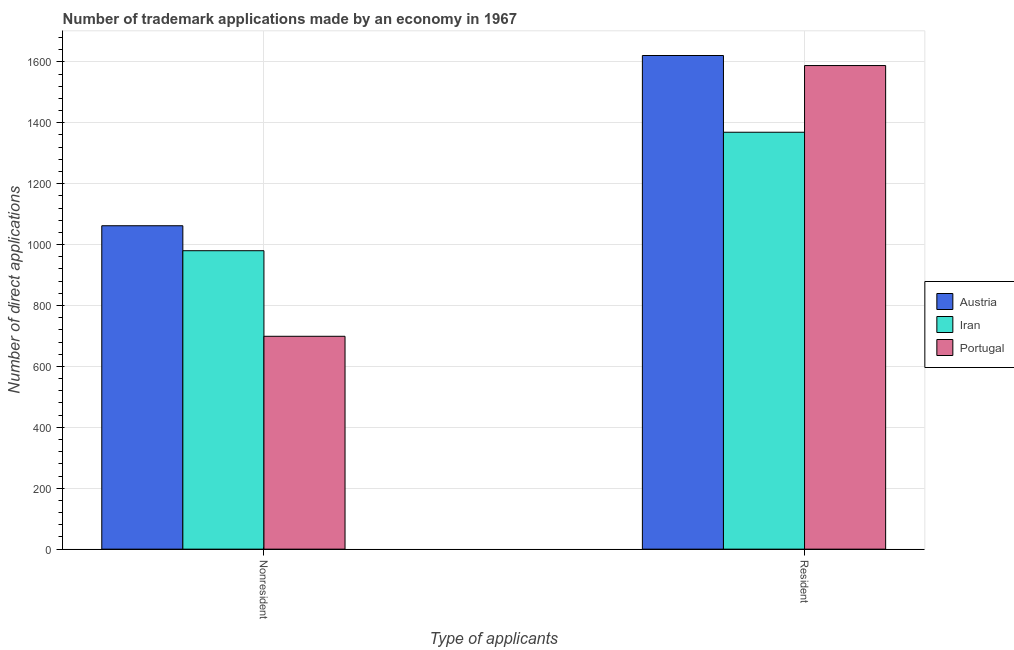How many bars are there on the 2nd tick from the left?
Offer a very short reply. 3. What is the label of the 1st group of bars from the left?
Your response must be concise. Nonresident. What is the number of trademark applications made by non residents in Portugal?
Provide a short and direct response. 699. Across all countries, what is the maximum number of trademark applications made by residents?
Your response must be concise. 1621. Across all countries, what is the minimum number of trademark applications made by residents?
Provide a succinct answer. 1369. In which country was the number of trademark applications made by residents minimum?
Your answer should be very brief. Iran. What is the total number of trademark applications made by residents in the graph?
Provide a short and direct response. 4578. What is the difference between the number of trademark applications made by non residents in Austria and that in Iran?
Provide a succinct answer. 82. What is the difference between the number of trademark applications made by residents in Iran and the number of trademark applications made by non residents in Austria?
Your response must be concise. 307. What is the average number of trademark applications made by non residents per country?
Provide a succinct answer. 913.67. What is the difference between the number of trademark applications made by non residents and number of trademark applications made by residents in Iran?
Give a very brief answer. -389. In how many countries, is the number of trademark applications made by non residents greater than 360 ?
Your answer should be compact. 3. What is the ratio of the number of trademark applications made by non residents in Iran to that in Austria?
Ensure brevity in your answer.  0.92. What does the 2nd bar from the left in Resident represents?
Offer a very short reply. Iran. What does the 1st bar from the right in Resident represents?
Give a very brief answer. Portugal. Are all the bars in the graph horizontal?
Give a very brief answer. No. What is the difference between two consecutive major ticks on the Y-axis?
Make the answer very short. 200. Does the graph contain grids?
Your response must be concise. Yes. Where does the legend appear in the graph?
Offer a terse response. Center right. How are the legend labels stacked?
Offer a terse response. Vertical. What is the title of the graph?
Your answer should be compact. Number of trademark applications made by an economy in 1967. What is the label or title of the X-axis?
Your response must be concise. Type of applicants. What is the label or title of the Y-axis?
Ensure brevity in your answer.  Number of direct applications. What is the Number of direct applications in Austria in Nonresident?
Your answer should be compact. 1062. What is the Number of direct applications of Iran in Nonresident?
Provide a short and direct response. 980. What is the Number of direct applications of Portugal in Nonresident?
Offer a terse response. 699. What is the Number of direct applications in Austria in Resident?
Keep it short and to the point. 1621. What is the Number of direct applications in Iran in Resident?
Provide a short and direct response. 1369. What is the Number of direct applications of Portugal in Resident?
Your answer should be very brief. 1588. Across all Type of applicants, what is the maximum Number of direct applications in Austria?
Provide a succinct answer. 1621. Across all Type of applicants, what is the maximum Number of direct applications of Iran?
Provide a succinct answer. 1369. Across all Type of applicants, what is the maximum Number of direct applications of Portugal?
Provide a succinct answer. 1588. Across all Type of applicants, what is the minimum Number of direct applications in Austria?
Provide a succinct answer. 1062. Across all Type of applicants, what is the minimum Number of direct applications of Iran?
Offer a terse response. 980. Across all Type of applicants, what is the minimum Number of direct applications in Portugal?
Ensure brevity in your answer.  699. What is the total Number of direct applications in Austria in the graph?
Your response must be concise. 2683. What is the total Number of direct applications in Iran in the graph?
Provide a succinct answer. 2349. What is the total Number of direct applications in Portugal in the graph?
Your answer should be very brief. 2287. What is the difference between the Number of direct applications in Austria in Nonresident and that in Resident?
Your response must be concise. -559. What is the difference between the Number of direct applications of Iran in Nonresident and that in Resident?
Give a very brief answer. -389. What is the difference between the Number of direct applications of Portugal in Nonresident and that in Resident?
Give a very brief answer. -889. What is the difference between the Number of direct applications of Austria in Nonresident and the Number of direct applications of Iran in Resident?
Make the answer very short. -307. What is the difference between the Number of direct applications of Austria in Nonresident and the Number of direct applications of Portugal in Resident?
Provide a short and direct response. -526. What is the difference between the Number of direct applications of Iran in Nonresident and the Number of direct applications of Portugal in Resident?
Give a very brief answer. -608. What is the average Number of direct applications in Austria per Type of applicants?
Your answer should be very brief. 1341.5. What is the average Number of direct applications of Iran per Type of applicants?
Provide a short and direct response. 1174.5. What is the average Number of direct applications in Portugal per Type of applicants?
Give a very brief answer. 1143.5. What is the difference between the Number of direct applications of Austria and Number of direct applications of Iran in Nonresident?
Provide a succinct answer. 82. What is the difference between the Number of direct applications in Austria and Number of direct applications in Portugal in Nonresident?
Offer a very short reply. 363. What is the difference between the Number of direct applications in Iran and Number of direct applications in Portugal in Nonresident?
Your answer should be compact. 281. What is the difference between the Number of direct applications in Austria and Number of direct applications in Iran in Resident?
Your answer should be compact. 252. What is the difference between the Number of direct applications in Iran and Number of direct applications in Portugal in Resident?
Your answer should be very brief. -219. What is the ratio of the Number of direct applications of Austria in Nonresident to that in Resident?
Provide a short and direct response. 0.66. What is the ratio of the Number of direct applications of Iran in Nonresident to that in Resident?
Give a very brief answer. 0.72. What is the ratio of the Number of direct applications of Portugal in Nonresident to that in Resident?
Provide a succinct answer. 0.44. What is the difference between the highest and the second highest Number of direct applications in Austria?
Keep it short and to the point. 559. What is the difference between the highest and the second highest Number of direct applications in Iran?
Your response must be concise. 389. What is the difference between the highest and the second highest Number of direct applications in Portugal?
Give a very brief answer. 889. What is the difference between the highest and the lowest Number of direct applications of Austria?
Your answer should be compact. 559. What is the difference between the highest and the lowest Number of direct applications of Iran?
Your response must be concise. 389. What is the difference between the highest and the lowest Number of direct applications in Portugal?
Offer a terse response. 889. 